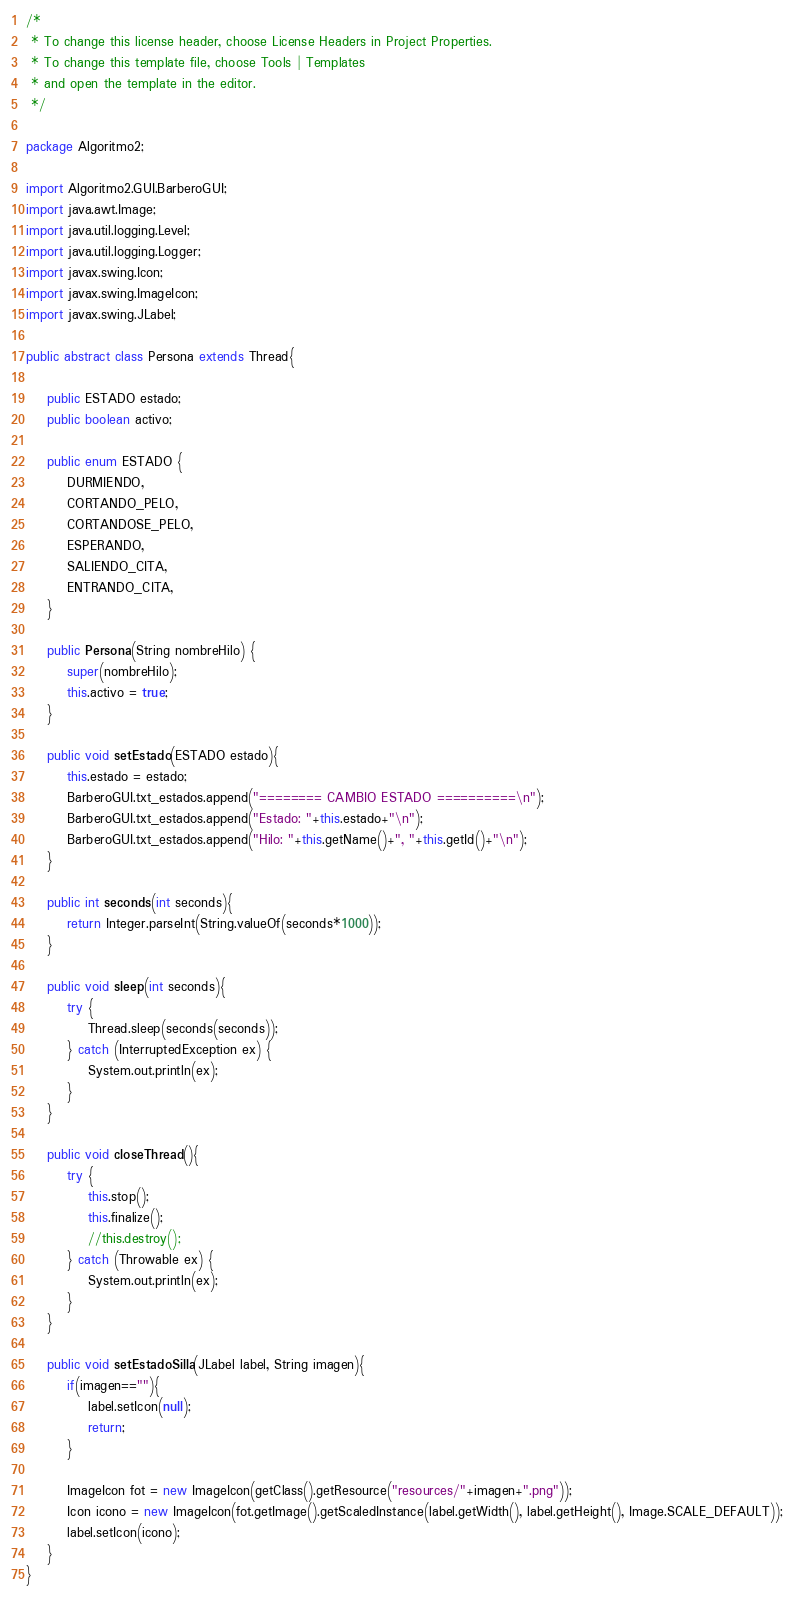<code> <loc_0><loc_0><loc_500><loc_500><_Java_>/*
 * To change this license header, choose License Headers in Project Properties.
 * To change this template file, choose Tools | Templates
 * and open the template in the editor.
 */

package Algoritmo2;

import Algoritmo2.GUI.BarberoGUI;
import java.awt.Image;
import java.util.logging.Level;
import java.util.logging.Logger;
import javax.swing.Icon;
import javax.swing.ImageIcon;
import javax.swing.JLabel;

public abstract class Persona extends Thread{
    
    public ESTADO estado;
    public boolean activo;
    
    public enum ESTADO {
        DURMIENDO,
        CORTANDO_PELO,
        CORTANDOSE_PELO,
        ESPERANDO,
        SALIENDO_CITA,
        ENTRANDO_CITA,
    }
    
    public Persona(String nombreHilo) {
        super(nombreHilo);
        this.activo = true;
    }
    
    public void setEstado(ESTADO estado){
        this.estado = estado;
        BarberoGUI.txt_estados.append("======== CAMBIO ESTADO ==========\n");
        BarberoGUI.txt_estados.append("Estado: "+this.estado+"\n");
        BarberoGUI.txt_estados.append("Hilo: "+this.getName()+", "+this.getId()+"\n");
    }
    
    public int seconds(int seconds){
        return Integer.parseInt(String.valueOf(seconds*1000));
    }
    
    public void sleep(int seconds){
        try {
            Thread.sleep(seconds(seconds));
        } catch (InterruptedException ex) {
            System.out.println(ex);
        }
    }
    
    public void closeThread(){
        try {
            this.stop();
            this.finalize();
            //this.destroy();
        } catch (Throwable ex) {
            System.out.println(ex);
        }
    }
    
    public void setEstadoSilla(JLabel label, String imagen){
        if(imagen==""){
            label.setIcon(null);
            return;
        }
        
        ImageIcon fot = new ImageIcon(getClass().getResource("resources/"+imagen+".png"));
        Icon icono = new ImageIcon(fot.getImage().getScaledInstance(label.getWidth(), label.getHeight(), Image.SCALE_DEFAULT));
        label.setIcon(icono);
    }
}
</code> 